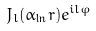Convert formula to latex. <formula><loc_0><loc_0><loc_500><loc_500>J _ { l } ( \alpha _ { \ln } r ) e ^ { i l \varphi }</formula> 